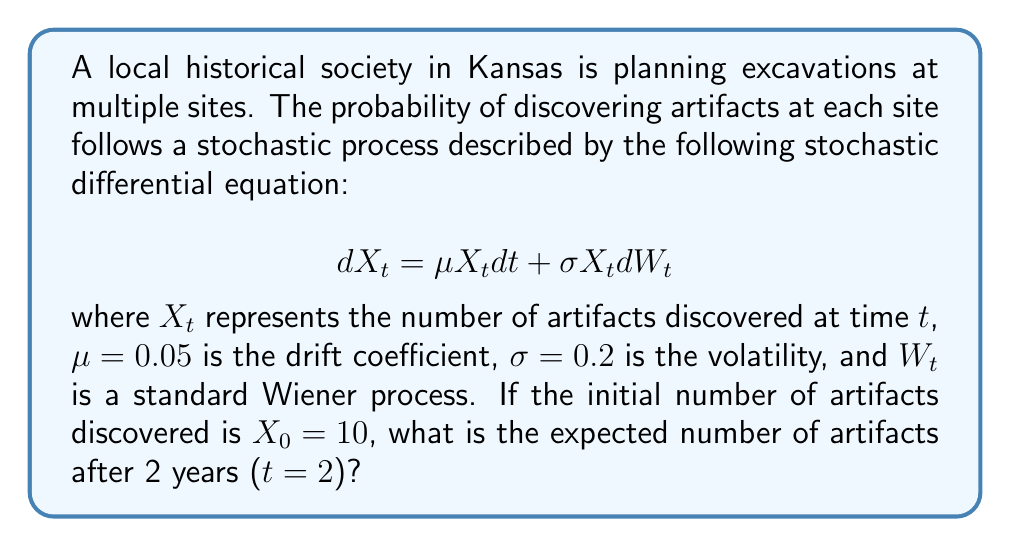Solve this math problem. To solve this problem, we'll use Itô's formula for geometric Brownian motion. The solution to the given stochastic differential equation is:

$$X_t = X_0 \exp\left(\left(\mu - \frac{\sigma^2}{2}\right)t + \sigma W_t\right)$$

To find the expected value, we use the property that $E[e^{\sigma W_t}] = e^{\frac{\sigma^2 t}{2}}$. Therefore:

$$E[X_t] = X_0 \exp\left(\mu t\right)$$

Let's substitute the given values:
$X_0 = 10$
$\mu = 0.05$
$t = 2$

$$E[X_2] = 10 \exp(0.05 \cdot 2)$$
$$E[X_2] = 10 \exp(0.1)$$
$$E[X_2] = 10 \cdot 1.1052$$
$$E[X_2] = 11.052$$

Therefore, the expected number of artifacts after 2 years is approximately 11.052.
Answer: 11.052 artifacts 